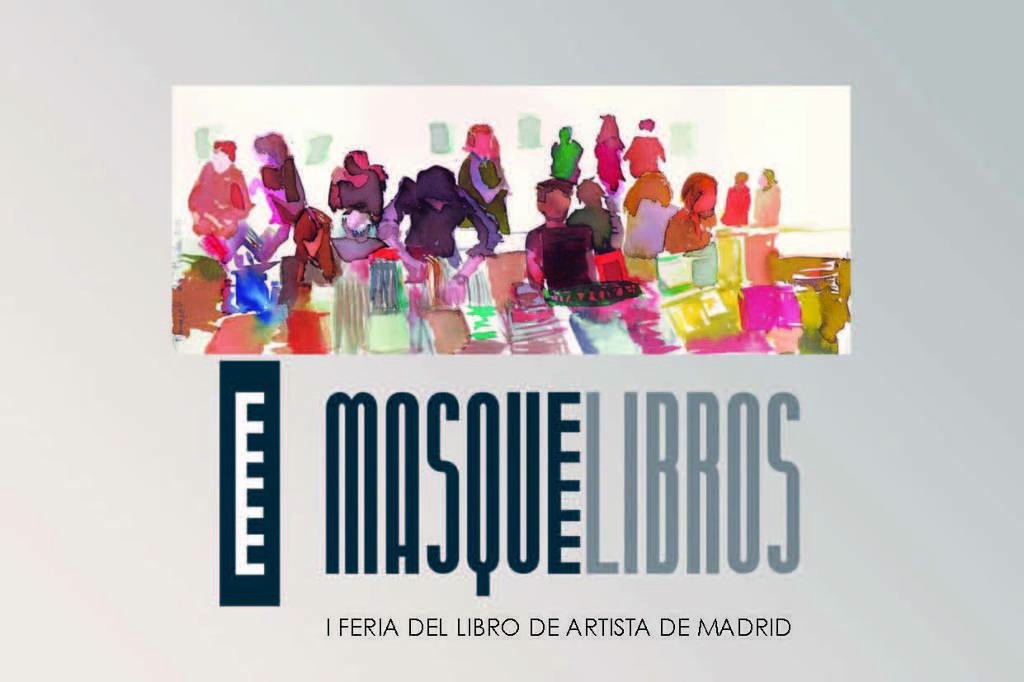What is the main object in the image? There is a poster in the image. What can be seen on the poster? There are people depicted in the poster, and there is text present in the poster. What is the aftermath of the thunderstorm in the image? There is no thunderstorm or aftermath present in the image; it only features a poster with people and text. 